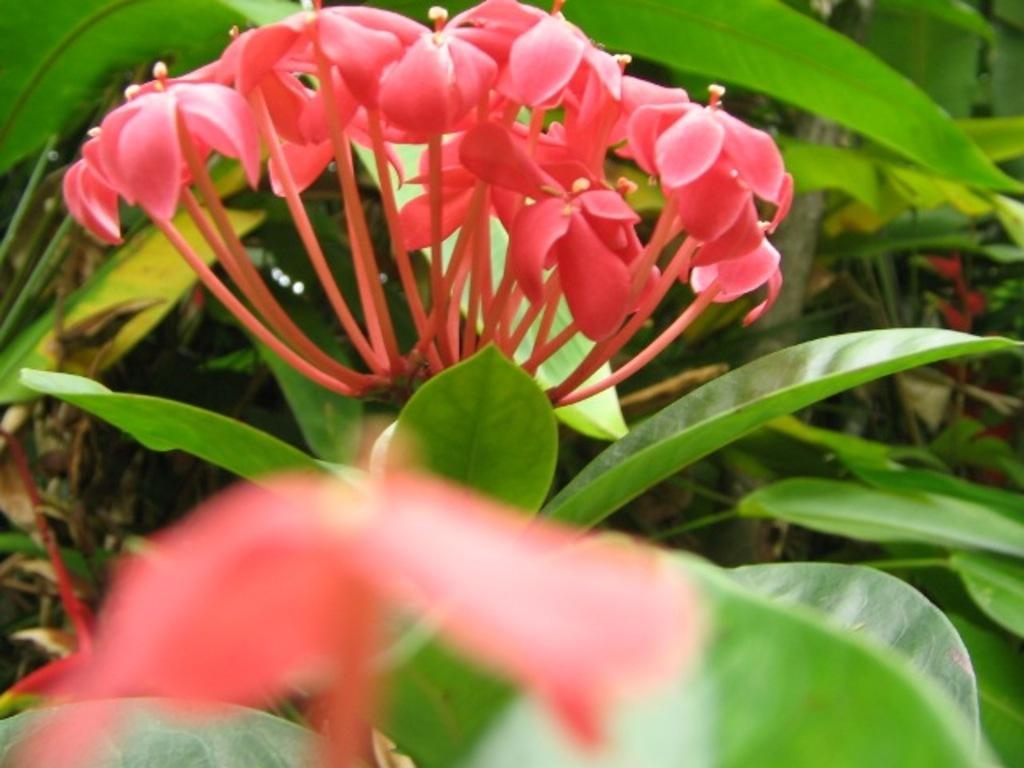Please provide a concise description of this image. In this picture we can see the flowers, green leaves, plants and some other objects. 